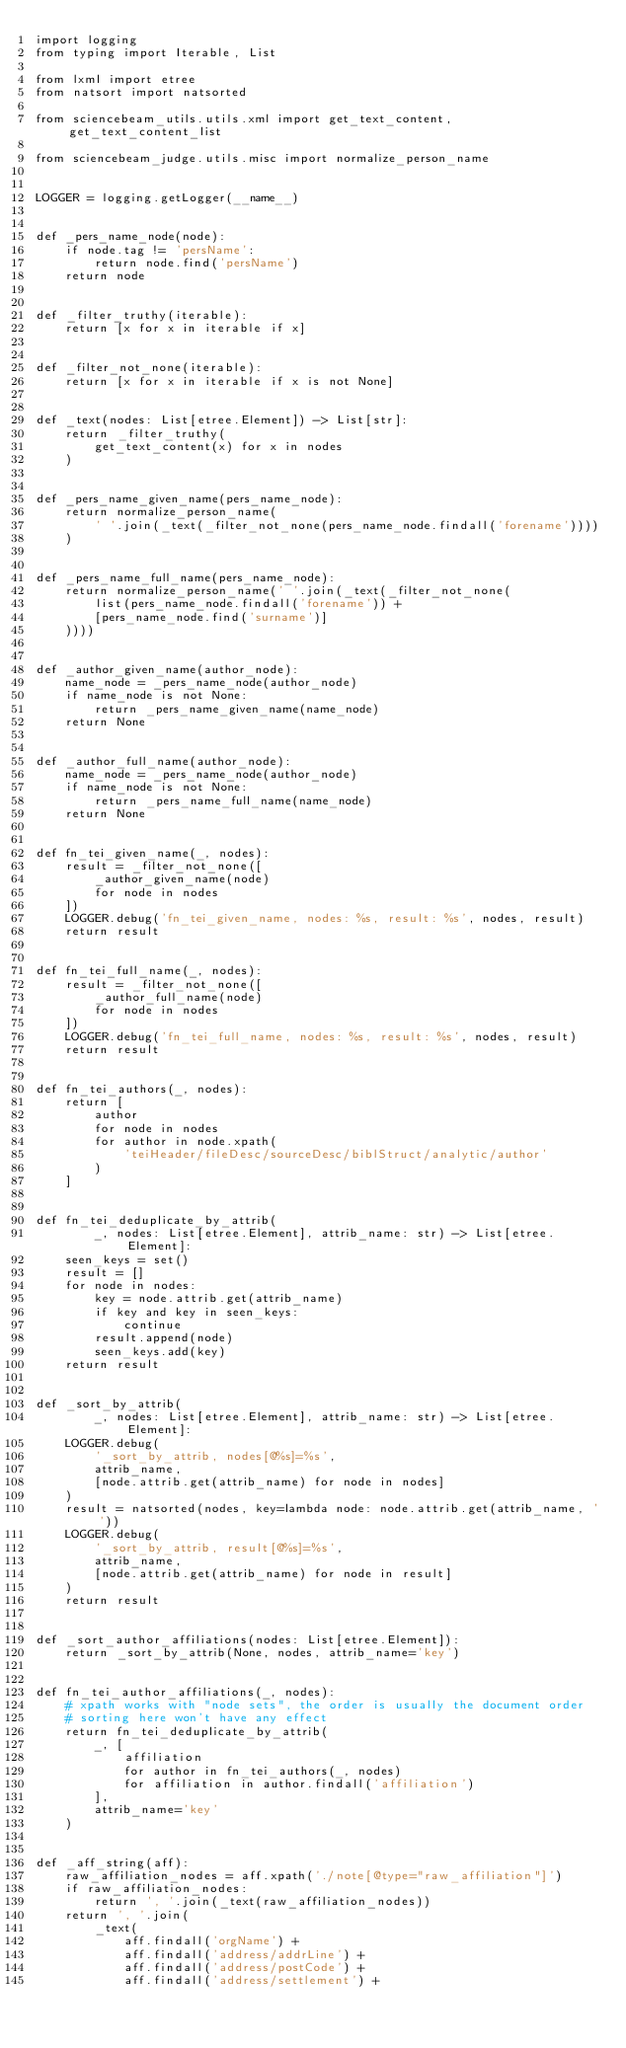<code> <loc_0><loc_0><loc_500><loc_500><_Python_>import logging
from typing import Iterable, List

from lxml import etree
from natsort import natsorted

from sciencebeam_utils.utils.xml import get_text_content, get_text_content_list

from sciencebeam_judge.utils.misc import normalize_person_name


LOGGER = logging.getLogger(__name__)


def _pers_name_node(node):
    if node.tag != 'persName':
        return node.find('persName')
    return node


def _filter_truthy(iterable):
    return [x for x in iterable if x]


def _filter_not_none(iterable):
    return [x for x in iterable if x is not None]


def _text(nodes: List[etree.Element]) -> List[str]:
    return _filter_truthy(
        get_text_content(x) for x in nodes
    )


def _pers_name_given_name(pers_name_node):
    return normalize_person_name(
        ' '.join(_text(_filter_not_none(pers_name_node.findall('forename'))))
    )


def _pers_name_full_name(pers_name_node):
    return normalize_person_name(' '.join(_text(_filter_not_none(
        list(pers_name_node.findall('forename')) +
        [pers_name_node.find('surname')]
    ))))


def _author_given_name(author_node):
    name_node = _pers_name_node(author_node)
    if name_node is not None:
        return _pers_name_given_name(name_node)
    return None


def _author_full_name(author_node):
    name_node = _pers_name_node(author_node)
    if name_node is not None:
        return _pers_name_full_name(name_node)
    return None


def fn_tei_given_name(_, nodes):
    result = _filter_not_none([
        _author_given_name(node)
        for node in nodes
    ])
    LOGGER.debug('fn_tei_given_name, nodes: %s, result: %s', nodes, result)
    return result


def fn_tei_full_name(_, nodes):
    result = _filter_not_none([
        _author_full_name(node)
        for node in nodes
    ])
    LOGGER.debug('fn_tei_full_name, nodes: %s, result: %s', nodes, result)
    return result


def fn_tei_authors(_, nodes):
    return [
        author
        for node in nodes
        for author in node.xpath(
            'teiHeader/fileDesc/sourceDesc/biblStruct/analytic/author'
        )
    ]


def fn_tei_deduplicate_by_attrib(
        _, nodes: List[etree.Element], attrib_name: str) -> List[etree.Element]:
    seen_keys = set()
    result = []
    for node in nodes:
        key = node.attrib.get(attrib_name)
        if key and key in seen_keys:
            continue
        result.append(node)
        seen_keys.add(key)
    return result


def _sort_by_attrib(
        _, nodes: List[etree.Element], attrib_name: str) -> List[etree.Element]:
    LOGGER.debug(
        '_sort_by_attrib, nodes[@%s]=%s',
        attrib_name,
        [node.attrib.get(attrib_name) for node in nodes]
    )
    result = natsorted(nodes, key=lambda node: node.attrib.get(attrib_name, ''))
    LOGGER.debug(
        '_sort_by_attrib, result[@%s]=%s',
        attrib_name,
        [node.attrib.get(attrib_name) for node in result]
    )
    return result


def _sort_author_affiliations(nodes: List[etree.Element]):
    return _sort_by_attrib(None, nodes, attrib_name='key')


def fn_tei_author_affiliations(_, nodes):
    # xpath works with "node sets", the order is usually the document order
    # sorting here won't have any effect
    return fn_tei_deduplicate_by_attrib(
        _, [
            affiliation
            for author in fn_tei_authors(_, nodes)
            for affiliation in author.findall('affiliation')
        ],
        attrib_name='key'
    )


def _aff_string(aff):
    raw_affiliation_nodes = aff.xpath('./note[@type="raw_affiliation"]')
    if raw_affiliation_nodes:
        return ', '.join(_text(raw_affiliation_nodes))
    return ', '.join(
        _text(
            aff.findall('orgName') +
            aff.findall('address/addrLine') +
            aff.findall('address/postCode') +
            aff.findall('address/settlement') +</code> 